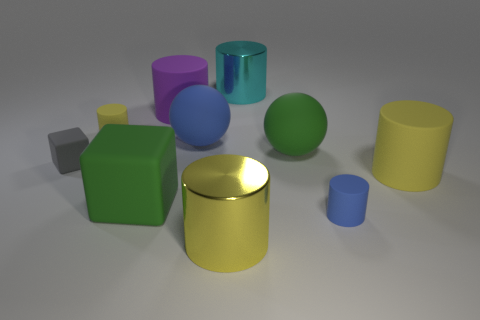What textures are visible on the surfaces of these objects, and what does that suggest about the material? The surfaces of these objects appear smooth and slightly reflective, which suggests they are made of rubber or a similar material with a matte finish. There's no apparent grain or roughness that would indicate a more textured material like wood or fabric. 